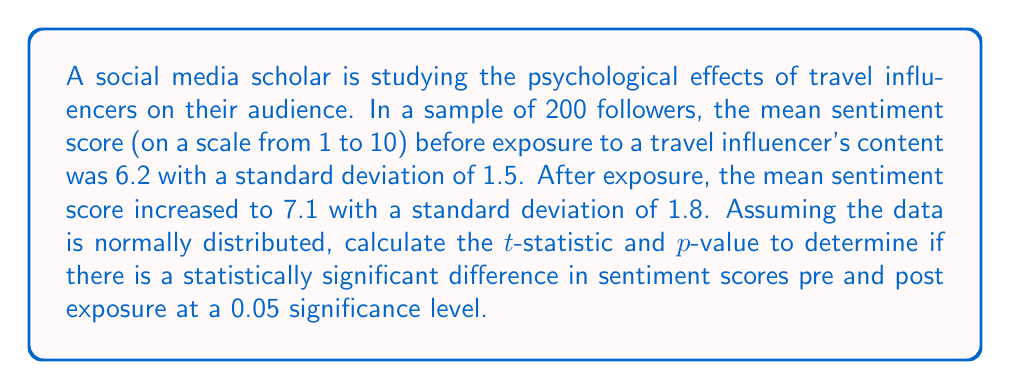What is the answer to this math problem? To determine if there is a statistically significant difference in sentiment scores, we'll use a paired t-test. Here are the steps:

1. Calculate the standard error of the difference:
   $$SE_d = \sqrt{\frac{s_1^2}{n} + \frac{s_2^2}{n}}$$
   Where $s_1$ and $s_2$ are the standard deviations, and $n$ is the sample size.
   $$SE_d = \sqrt{\frac{1.5^2}{200} + \frac{1.8^2}{200}} = \sqrt{\frac{2.25}{200} + \frac{3.24}{200}} = \sqrt{0.02745} = 0.1657$$

2. Calculate the t-statistic:
   $$t = \frac{\bar{x}_2 - \bar{x}_1}{SE_d}$$
   Where $\bar{x}_1$ and $\bar{x}_2$ are the mean scores before and after exposure.
   $$t = \frac{7.1 - 6.2}{0.1657} = \frac{0.9}{0.1657} = 5.4316$$

3. Determine the degrees of freedom:
   $df = n - 1 = 200 - 1 = 199$

4. Find the critical t-value for a two-tailed test at 0.05 significance level with 199 degrees of freedom:
   $t_{crit} = \pm 1.9720$ (from t-distribution table)

5. Calculate the p-value:
   Using a t-distribution calculator or table, we find that the p-value for t = 5.4316 and df = 199 is p < 0.00001.

6. Compare the t-statistic to the critical value and interpret the p-value:
   The absolute value of the t-statistic (5.4316) is greater than the critical value (1.9720), and the p-value (< 0.00001) is less than the significance level (0.05).
Answer: t = 5.4316, p < 0.00001; statistically significant difference 